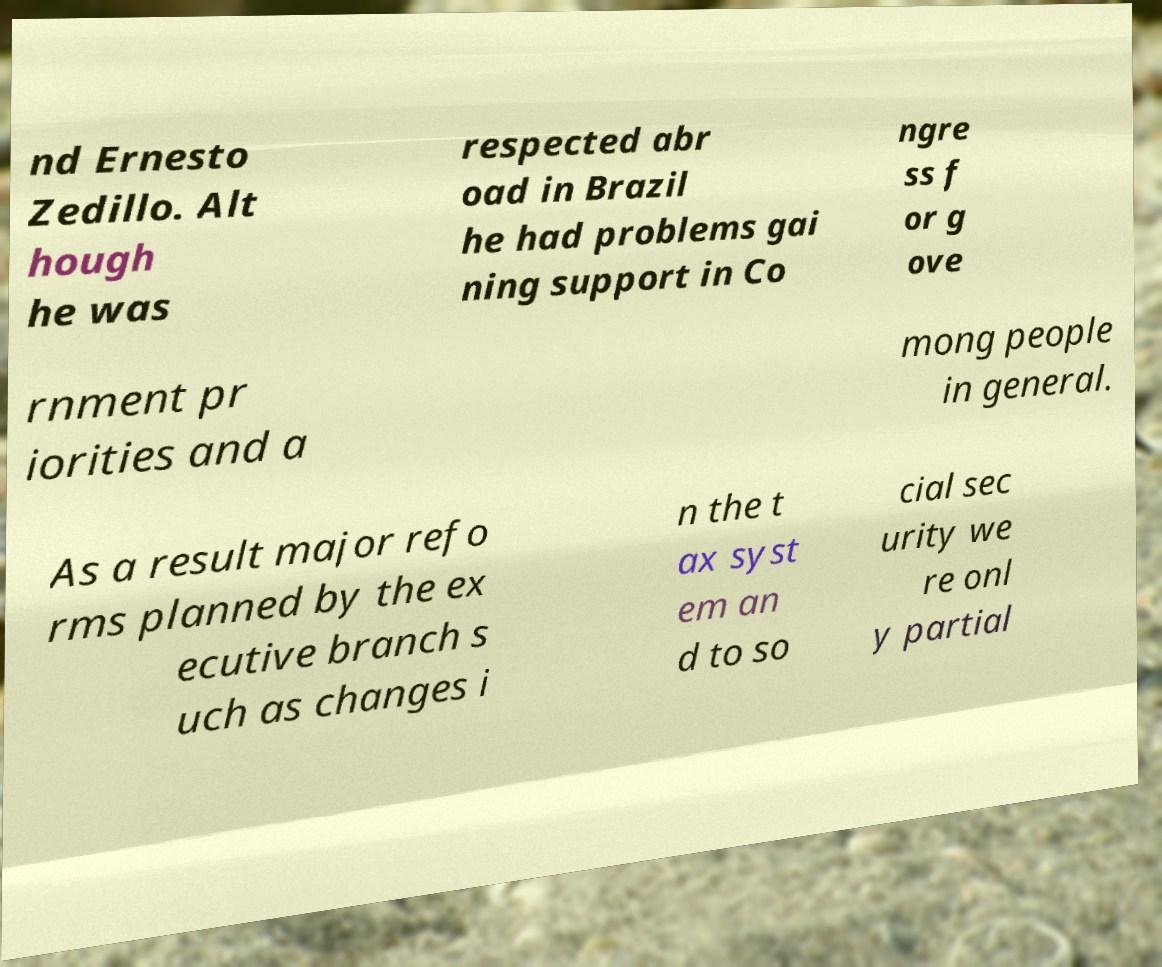Could you assist in decoding the text presented in this image and type it out clearly? nd Ernesto Zedillo. Alt hough he was respected abr oad in Brazil he had problems gai ning support in Co ngre ss f or g ove rnment pr iorities and a mong people in general. As a result major refo rms planned by the ex ecutive branch s uch as changes i n the t ax syst em an d to so cial sec urity we re onl y partial 